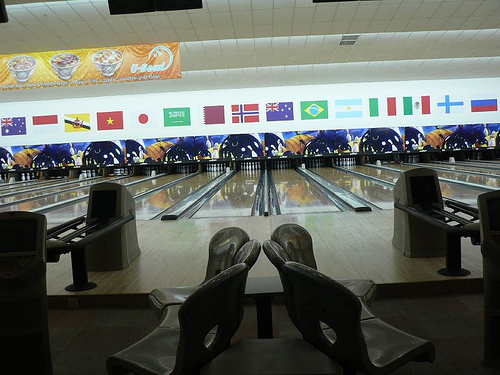<image>
Is there a chair above the chair? No. The chair is not positioned above the chair. The vertical arrangement shows a different relationship. 